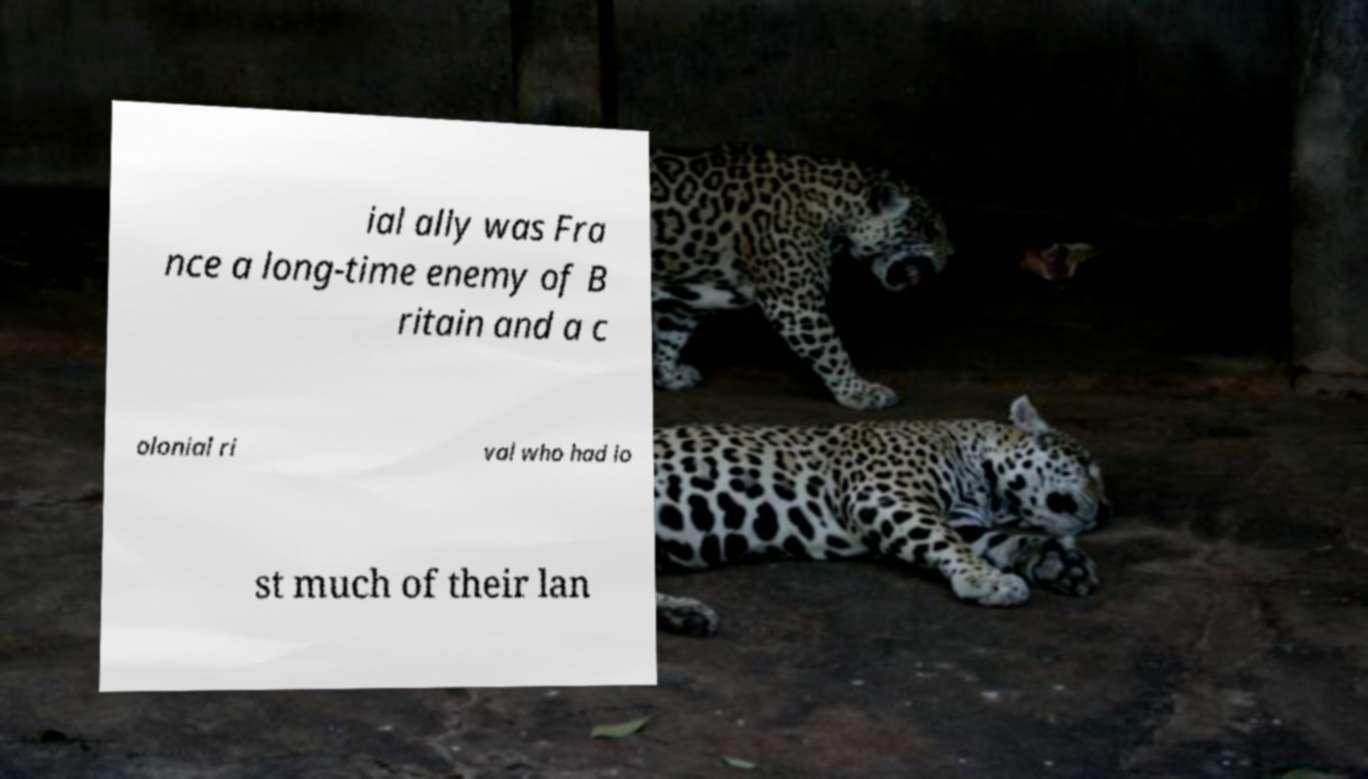Can you accurately transcribe the text from the provided image for me? ial ally was Fra nce a long-time enemy of B ritain and a c olonial ri val who had lo st much of their lan 